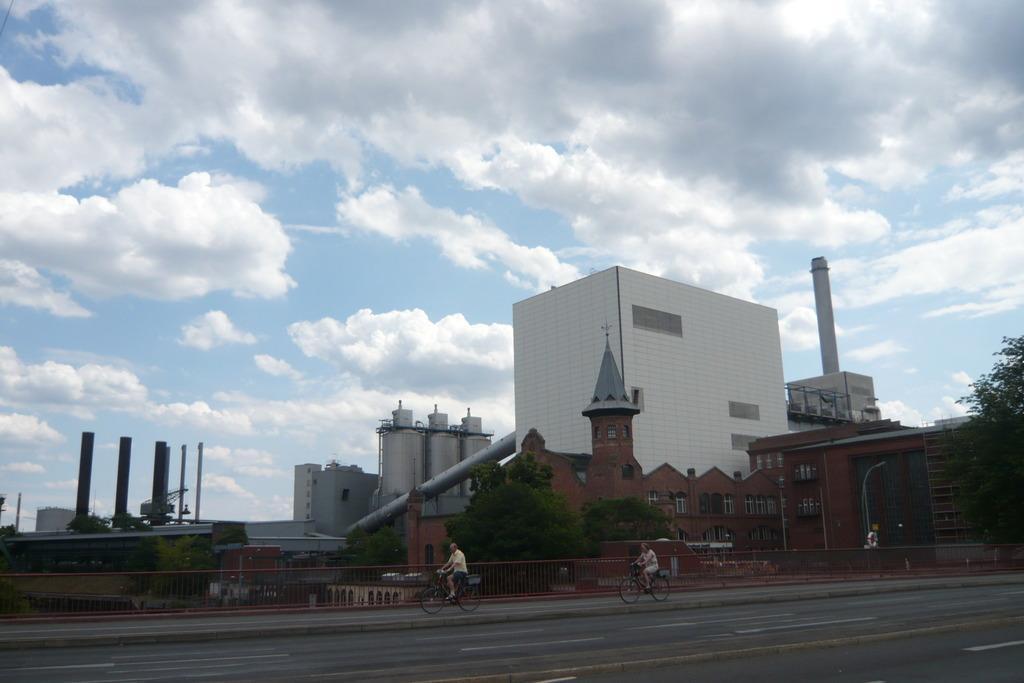How would you summarize this image in a sentence or two? In this image there is the sky, there are clouds in the sky, there are buildings, there are towers, there is a tree truncated towards the right of the image, there is a fencing truncated, there is road truncated towards the bottom of the image, there are bicycles on the road, there are two persons riding bicycles, there are poles, there is an object truncated towards the left of the image. 